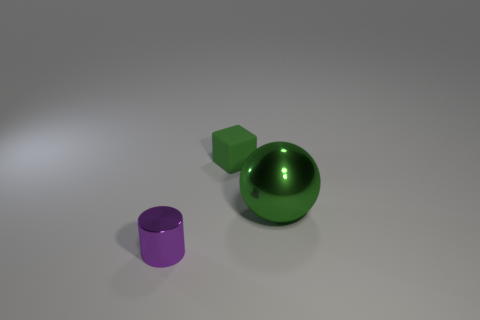Subtract all blue spheres. Subtract all gray cylinders. How many spheres are left? 1 Subtract all purple cylinders. How many brown balls are left? 0 Add 1 big cyans. How many things exist? 0 Subtract all green balls. Subtract all tiny blue spheres. How many objects are left? 2 Add 1 big green metallic balls. How many big green metallic balls are left? 2 Add 2 big shiny things. How many big shiny things exist? 3 Add 3 big red matte things. How many objects exist? 6 Subtract 0 blue blocks. How many objects are left? 3 Subtract all spheres. How many objects are left? 2 Subtract 1 spheres. How many spheres are left? 0 